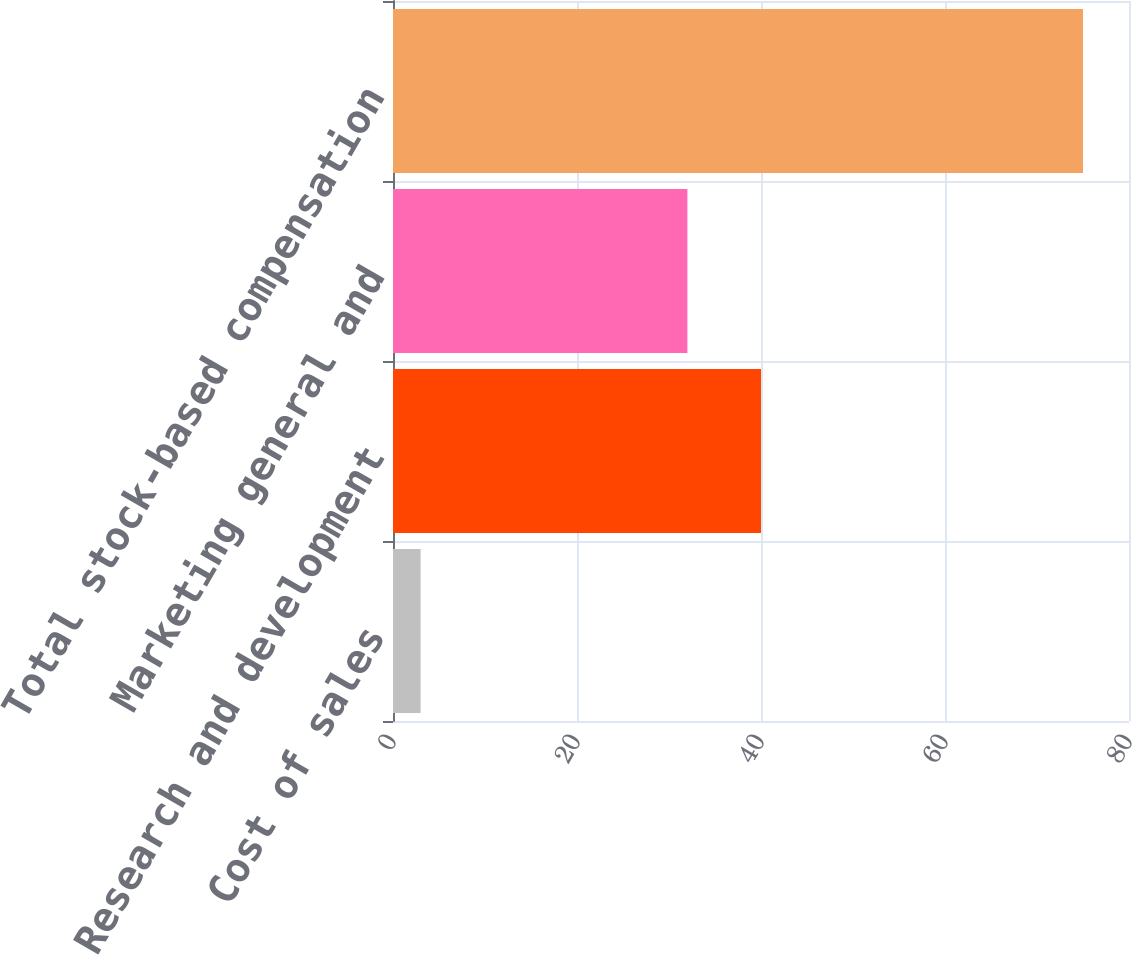<chart> <loc_0><loc_0><loc_500><loc_500><bar_chart><fcel>Cost of sales<fcel>Research and development<fcel>Marketing general and<fcel>Total stock-based compensation<nl><fcel>3<fcel>40<fcel>32<fcel>75<nl></chart> 